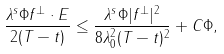Convert formula to latex. <formula><loc_0><loc_0><loc_500><loc_500>\frac { \lambda ^ { s } \Phi f ^ { \perp } \cdot E } { 2 ( T - t ) } \leq \frac { \lambda ^ { s } \Phi | f ^ { \perp } | ^ { 2 } } { 8 \lambda _ { 0 } ^ { 2 } ( T - t ) ^ { 2 } } + C \Phi ,</formula> 